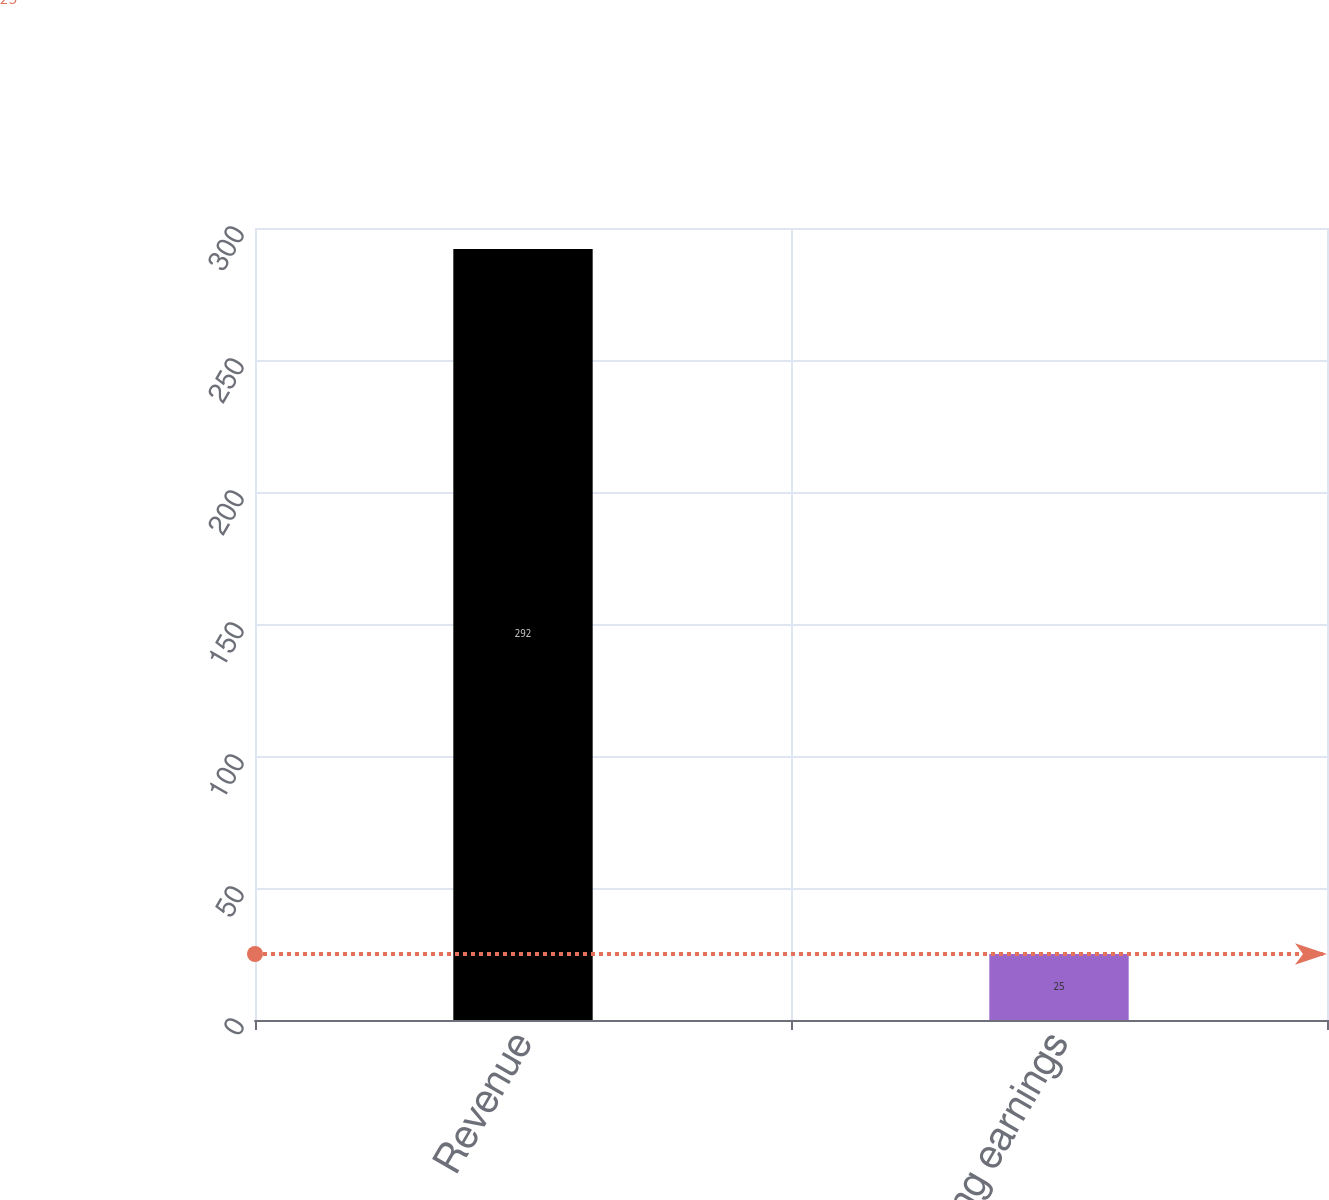Convert chart. <chart><loc_0><loc_0><loc_500><loc_500><bar_chart><fcel>Revenue<fcel>Operating earnings<nl><fcel>292<fcel>25<nl></chart> 